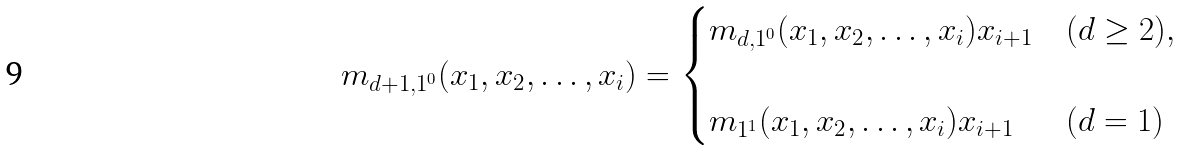<formula> <loc_0><loc_0><loc_500><loc_500>m _ { d + 1 , 1 ^ { 0 } } ( x _ { 1 } , x _ { 2 } , \dots , x _ { i } ) = \begin{cases} m _ { d , 1 ^ { 0 } } ( x _ { 1 } , x _ { 2 } , \dots , x _ { i } ) x _ { i + 1 } & ( d \geq 2 ) , \\ \\ m _ { 1 ^ { 1 } } ( x _ { 1 } , x _ { 2 } , \dots , x _ { i } ) x _ { i + 1 } & ( d = 1 ) \end{cases}</formula> 